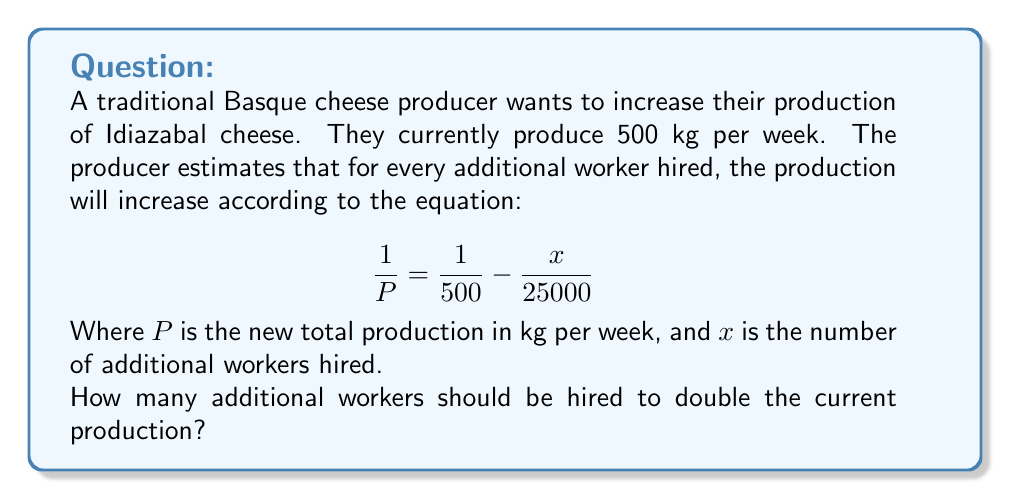Show me your answer to this math problem. Let's solve this step-by-step:

1) We want to double the current production, so $P = 1000$ kg.

2) Substitute this into the equation:

   $$\frac{1}{1000} = \frac{1}{500} - \frac{x}{25000}$$

3) Multiply both sides by 25000:

   $$\frac{25000}{1000} = \frac{25000}{500} - x$$

4) Simplify:

   $$25 = 50 - x$$

5) Subtract 50 from both sides:

   $$-25 = -x$$

6) Multiply both sides by -1:

   $$25 = x$$

Therefore, 25 additional workers should be hired to double the production.
Answer: 25 workers 